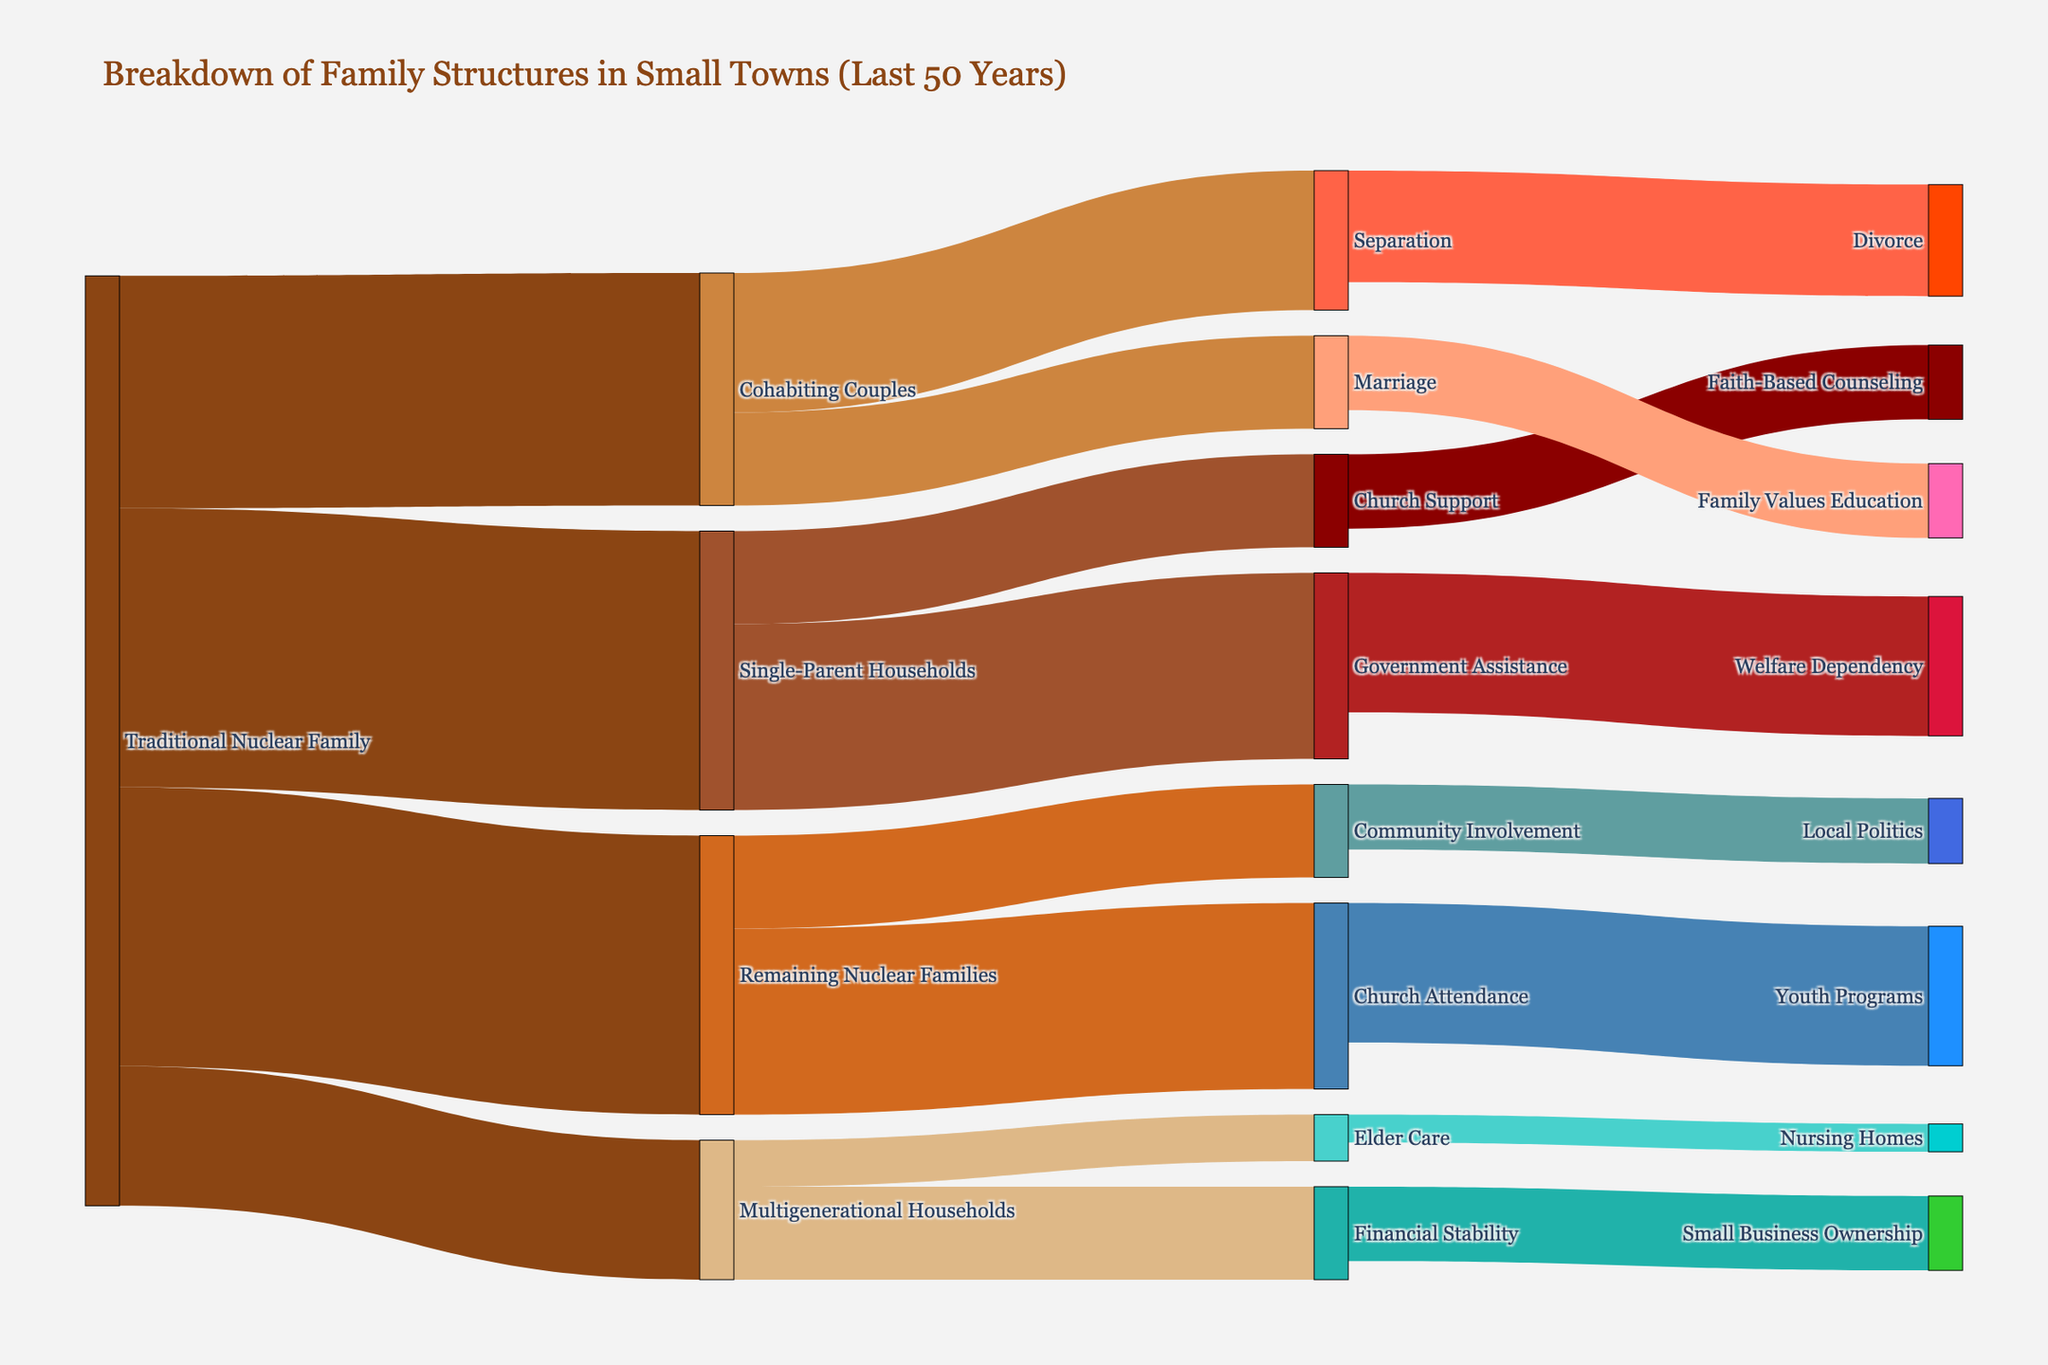What's the title of the figure? The title is typically displayed at the top of the Sankey diagram, and it provides a summary of what the figure represents.
Answer: Breakdown of Family Structures in Small Towns (Last 50 Years) How many family structures are represented as "Remaining Nuclear Families"? The "Traditional Nuclear Family" splits into several categories, one of which is "Remaining Nuclear Families." The diagram shows the value associated with this split.
Answer: 30 Which source has the highest value transitioning to "Divorce"? The target "Divorce" has arrows leading into it, and one can refer to the labels and values on those arrows to determine the source with the highest contribution.
Answer: Separation What is the total value flowing from "Single-Parent Households"? To find the total value from "Single-Parent Households," add up all the values that originate from this category.
Answer: 30 Compare the values flowing from "Cohabiting Couples" to "Marriage" and "Separation." Which is higher? Compare the arrows originating from "Cohabiting Couples" leading to "Marriage" and "Separation," and identify which has a higher value.
Answer: Separation What is the value of "Church Attendance" transitioning to "Youth Programs"? Identify the flow between "Church Attendance" and "Youth Programs" in the Sankey diagram to find the corresponding value.
Answer: 15 How many categories does the "Traditional Nuclear Family" split into? Count the distinct labels that the "Traditional Nuclear Family" transitions into in the diagram.
Answer: 4 What is the combined value transitioning from "Multigenerational Households"? Add up the values of all arrows that transition from "Multigenerational Households" to any other target.
Answer: 15 Which category receives the least value from "Government Assistance"? Compare the values of all the transitions from "Government Assistance" and identify the one with the smallest value.
Answer: Welfare Dependency What is the primary support system for "Single-Parent Households" based on the highest flow value? Review the transitions from "Single-Parent Households" and identify the one with the highest value, indicating the primary support system.
Answer: Government Assistance 